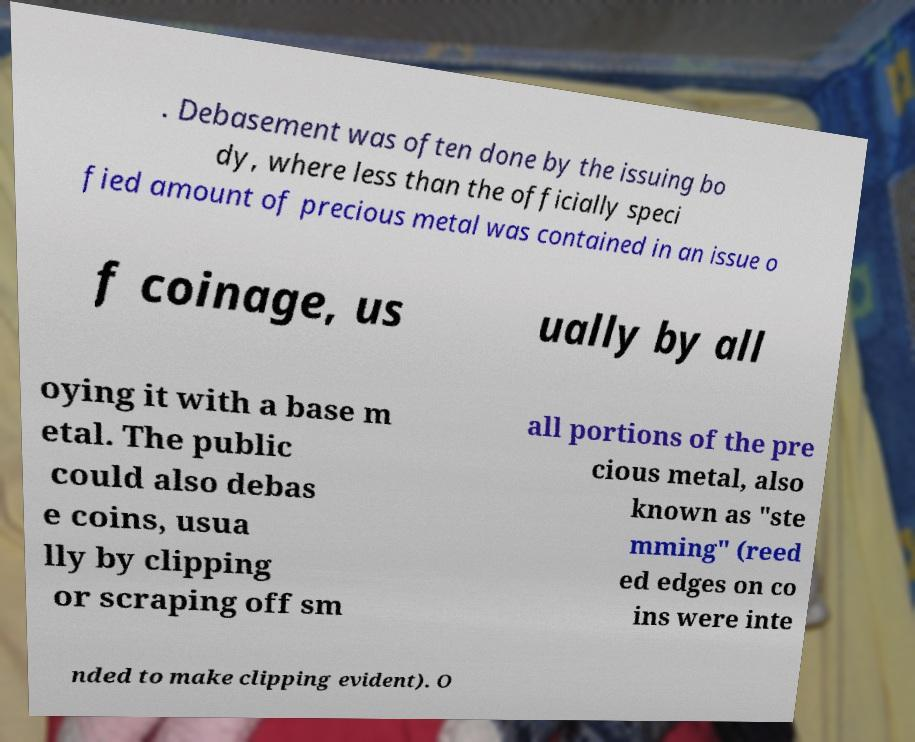Can you accurately transcribe the text from the provided image for me? . Debasement was often done by the issuing bo dy, where less than the officially speci fied amount of precious metal was contained in an issue o f coinage, us ually by all oying it with a base m etal. The public could also debas e coins, usua lly by clipping or scraping off sm all portions of the pre cious metal, also known as "ste mming" (reed ed edges on co ins were inte nded to make clipping evident). O 